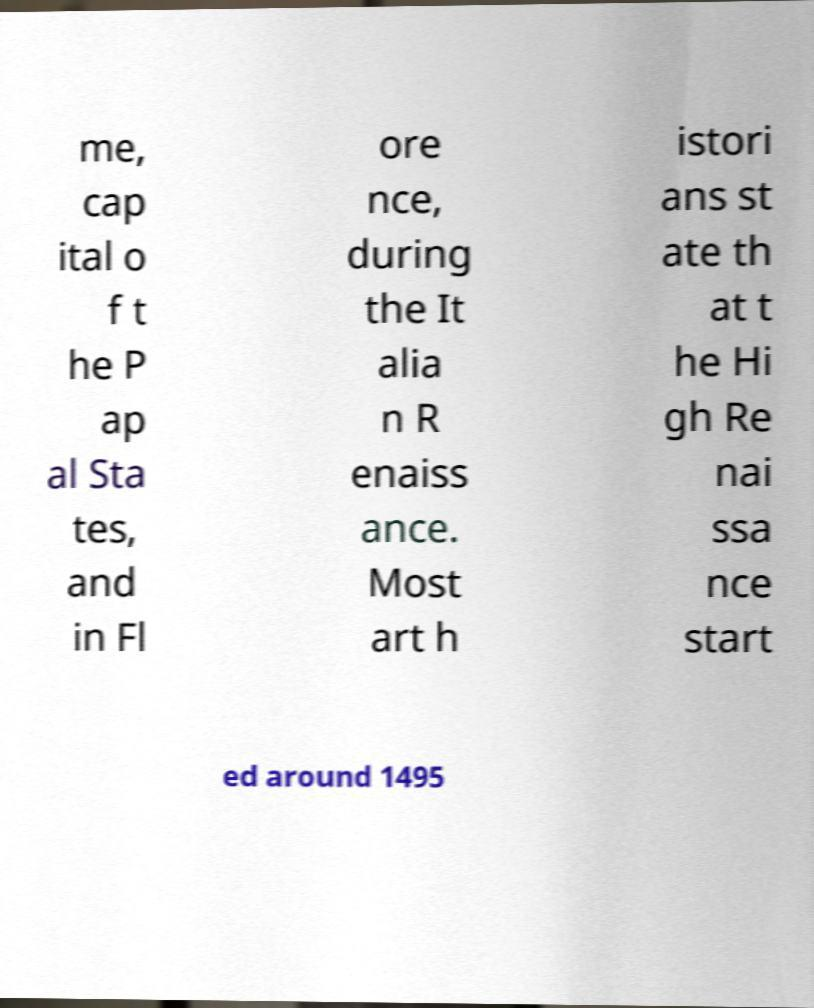Please read and relay the text visible in this image. What does it say? me, cap ital o f t he P ap al Sta tes, and in Fl ore nce, during the It alia n R enaiss ance. Most art h istori ans st ate th at t he Hi gh Re nai ssa nce start ed around 1495 